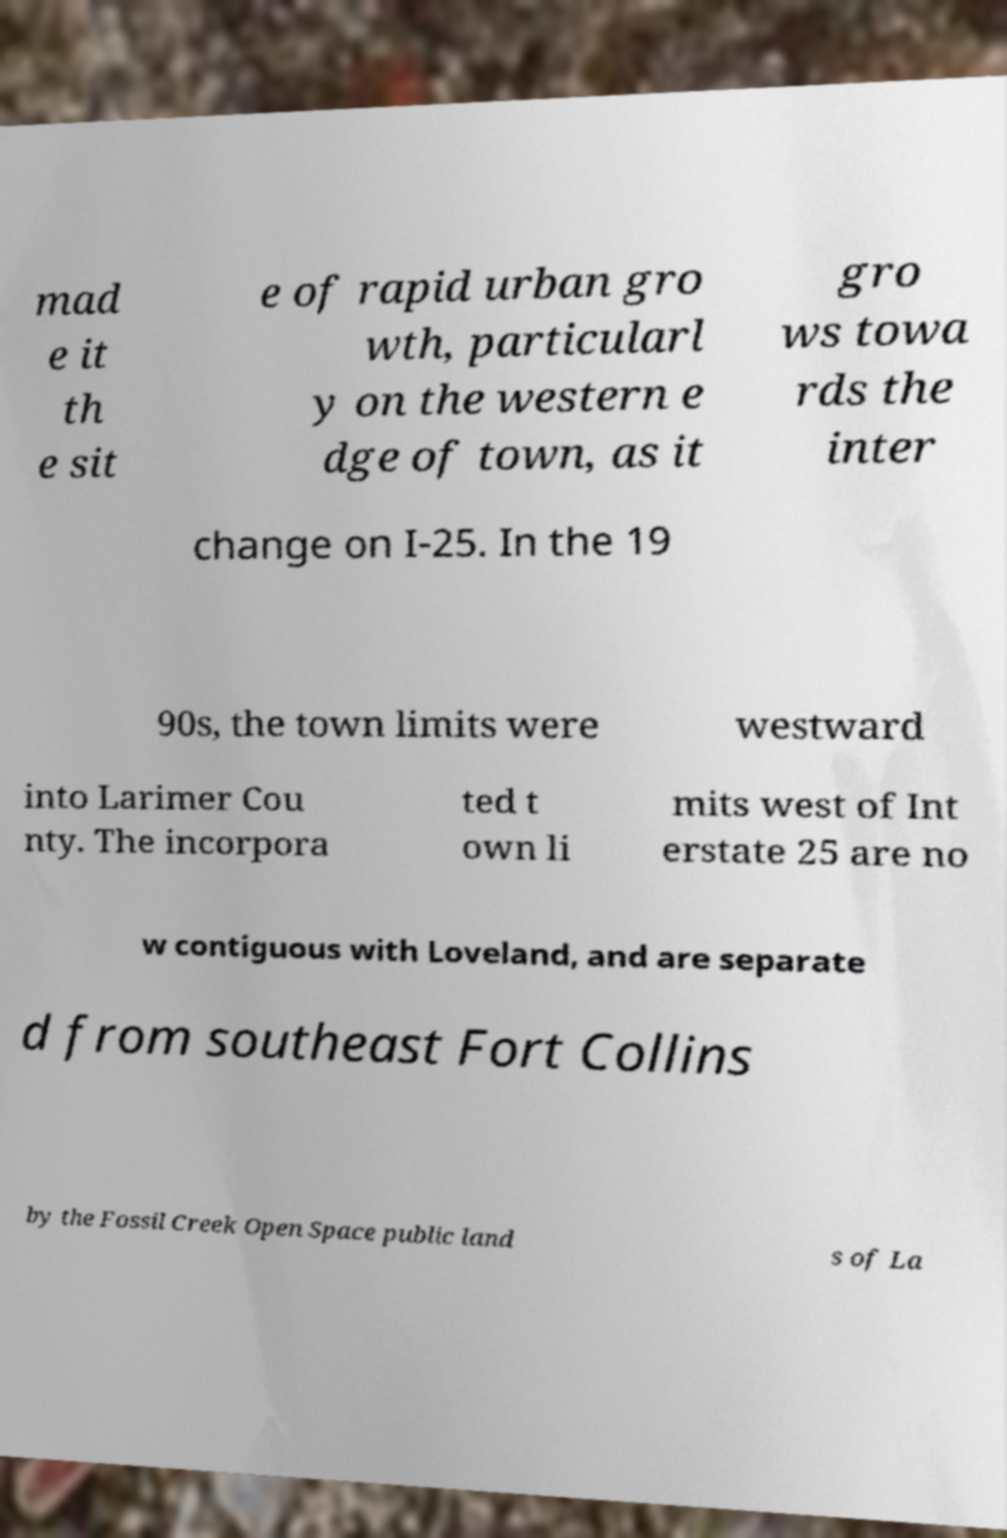Please identify and transcribe the text found in this image. mad e it th e sit e of rapid urban gro wth, particularl y on the western e dge of town, as it gro ws towa rds the inter change on I-25. In the 19 90s, the town limits were westward into Larimer Cou nty. The incorpora ted t own li mits west of Int erstate 25 are no w contiguous with Loveland, and are separate d from southeast Fort Collins by the Fossil Creek Open Space public land s of La 